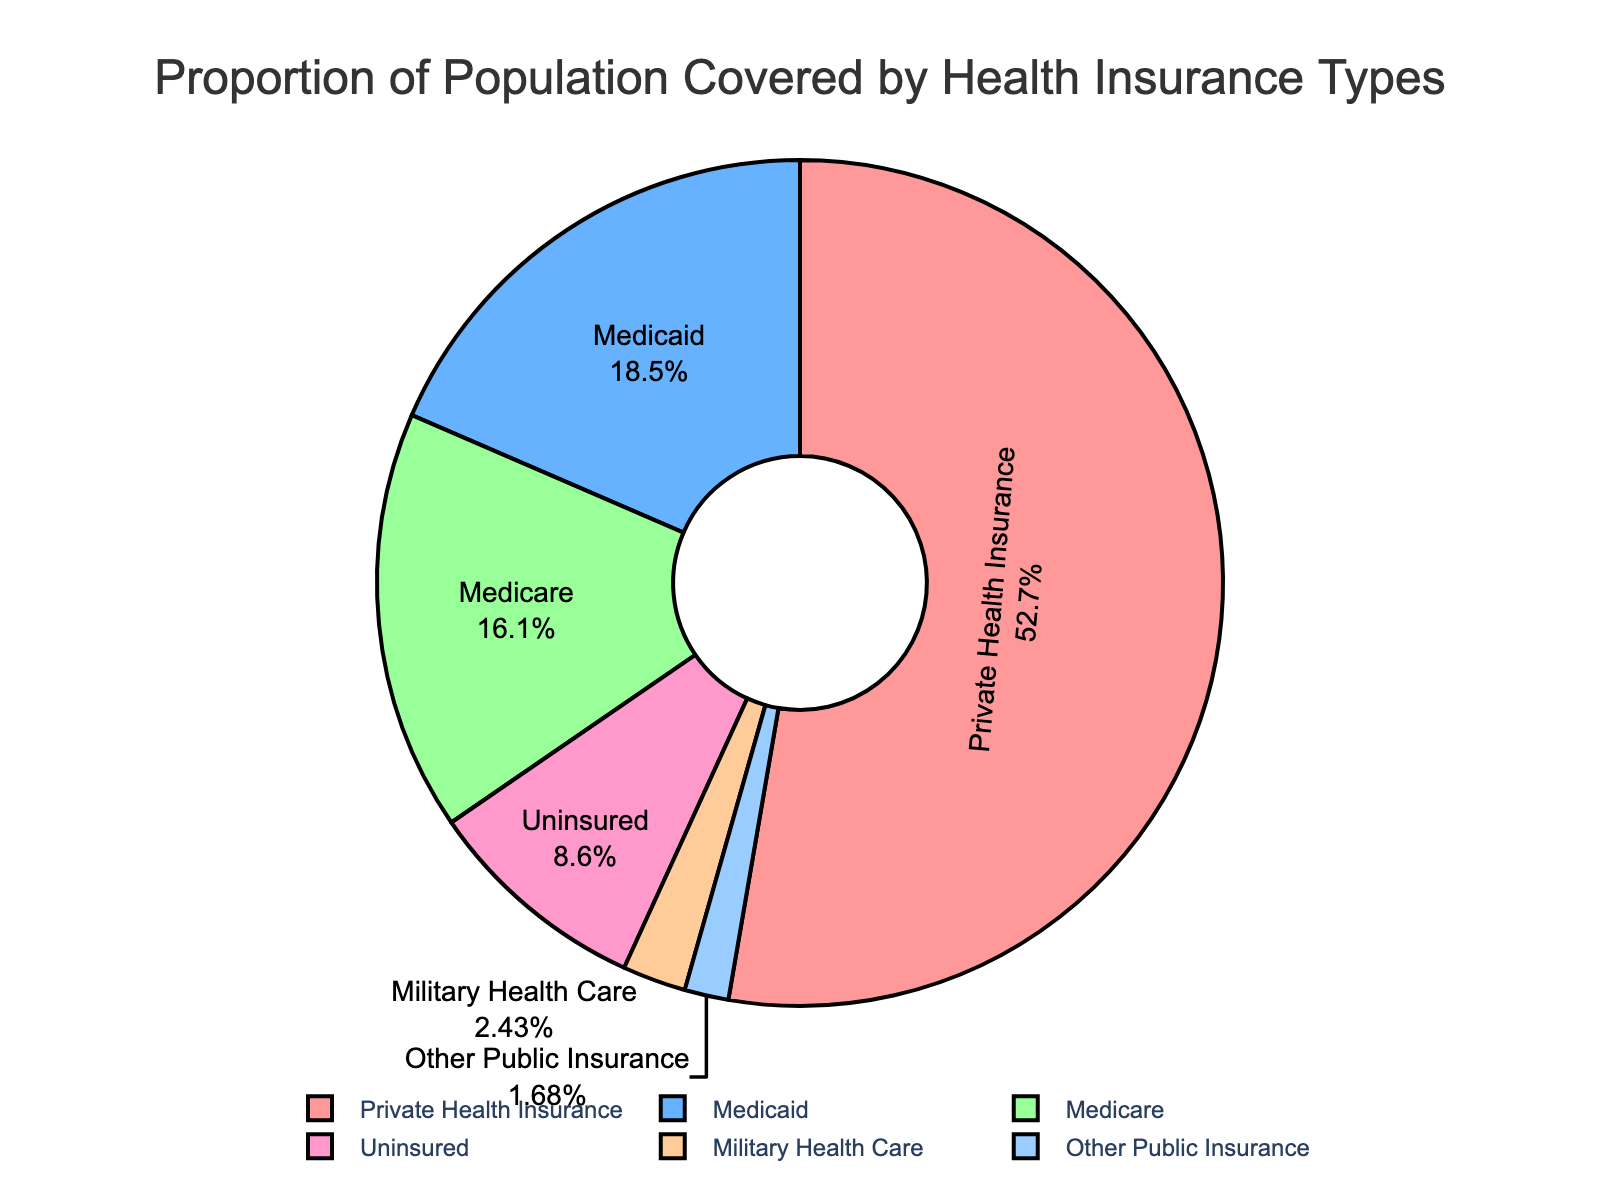What percentage of the population is covered by Medicaid and Medicare combined? To find the combined percentage of the population covered by Medicaid and Medicare, sum their individual percentages. Medicaid covers 19.8% and Medicare covers 17.2%. So, 19.8 + 17.2 = 37.
Answer: 37% Which insurance type covers the largest proportion of the population? Refer to the figure and identify the largest segment. The largest segment is represented by Private Health Insurance at 56.4%.
Answer: Private Health Insurance Among the insurance types, which one covers a smaller proportion of the population than Military Health Care? Refer to the figure and compare the percentages. Military Health Care covers 2.6%, and the only type with a smaller percentage is Other Public Insurance at 1.8%.
Answer: Other Public Insurance How much more of the population is covered by Private Health Insurance compared to Uninsured? Find the difference between the percentages of Private Health Insurance and Uninsured. Private Health Insurance covers 56.4% while Uninsured covers 9.2%. The difference is 56.4 - 9.2 = 47.2.
Answer: 47.2% What is the total proportion of the population covered by Other Public Insurance and Military Health Care? To find the combined proportion, add the percentages of Other Public Insurance and Military Health Care. Other Public Insurance covers 1.8% and Military Health Care covers 2.6%. So, 1.8 + 2.6 = 4.4.
Answer: 4.4% Is the proportion of the Uninsured population greater or lesser than the proportion covered by Medicare? Compare the percentages of the Uninsured population (9.2%) and Medicare (17.2%). The proportion of the Uninsured population is lesser.
Answer: Lesser What color represents Medicaid? Refer to the figure and identify the color of the segment labeled "Medicaid". Medicaid is represented by the blue segment.
Answer: Blue Which insurance types have a percentage less than 10%? Identify the segments with percentages less than 10%. The insurance types are Military Health Care (2.6%), Uninsured (9.2%), and Other Public Insurance (1.8%).
Answer: Military Health Care, Uninsured, Other Public Insurance 